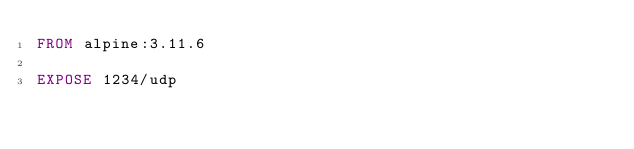<code> <loc_0><loc_0><loc_500><loc_500><_Dockerfile_>FROM alpine:3.11.6

EXPOSE 1234/udp</code> 